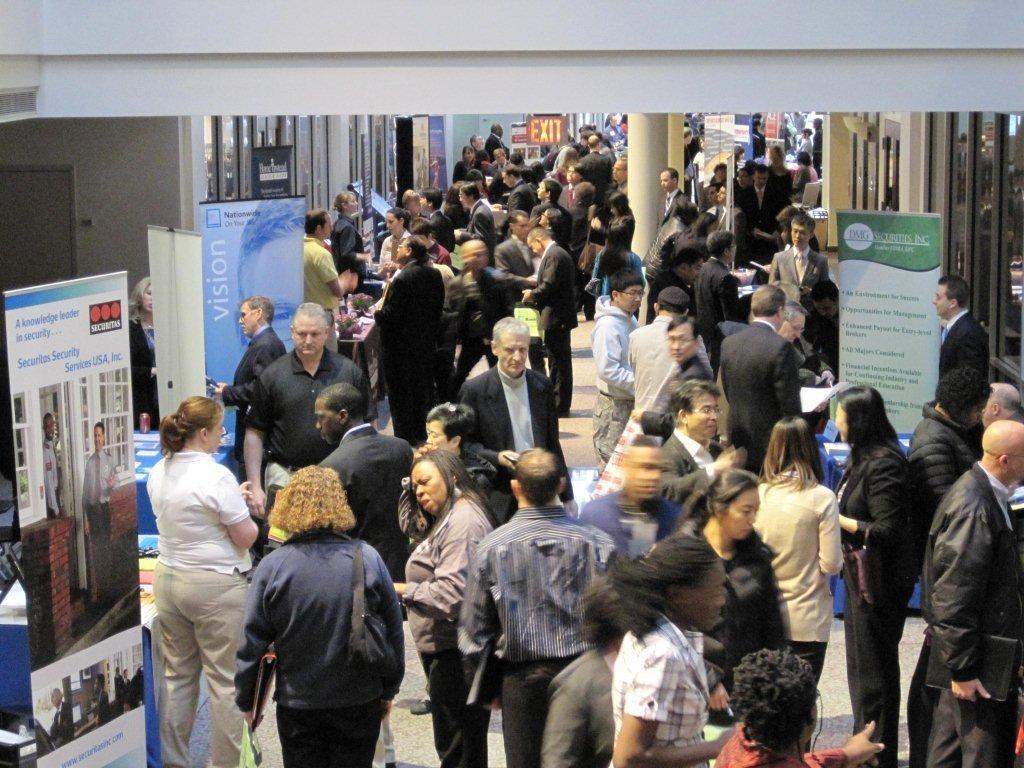How would you summarize this image in a sentence or two? In this image I can see the ground, number of persons standing on the ground, few banners, few pillars, a exit board and few buildings. 